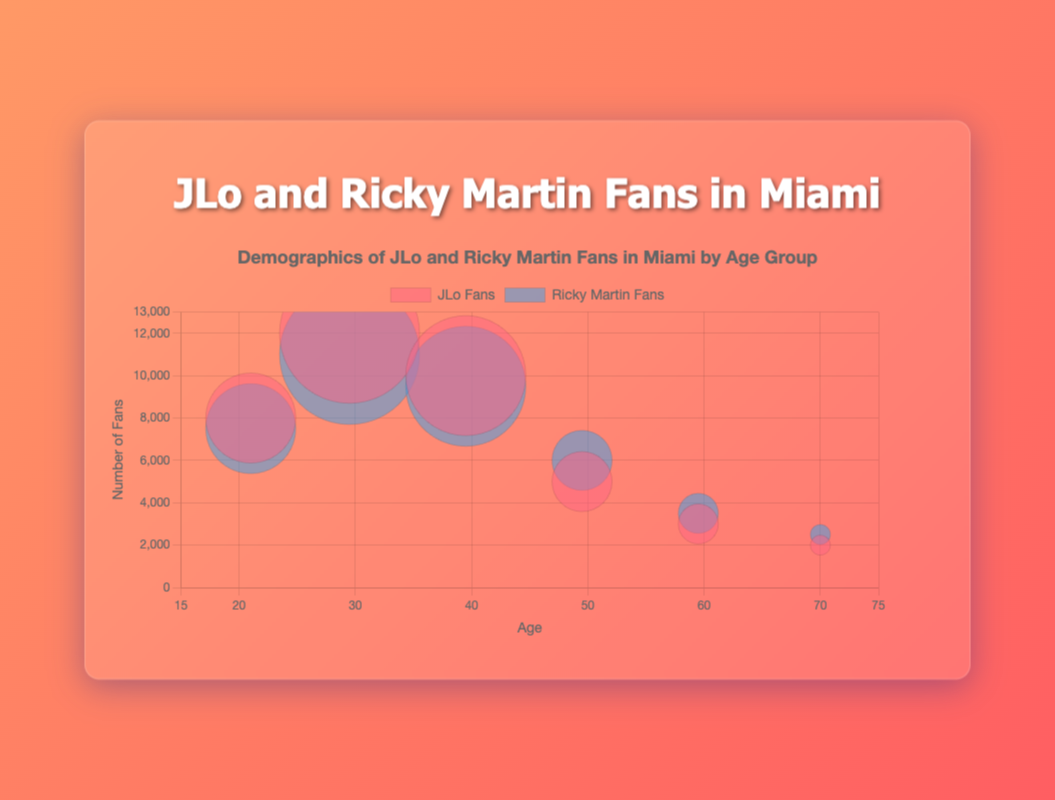What is the title of the chart? The title of the chart is located at the top and provides a summary of what the visual representation is about. The title reads "Demographics of JLo and Ricky Martin Fans in Miami by Age Group."
Answer: Demographics of JLo and Ricky Martin Fans in Miami by Age Group Which age group has the highest number of JLo fans? By looking at the y-axis values of the red bubbles (representing JLo fans), we can see which bubble goes the highest. The 25-34 age group has the highest y-coordinate at 12,000 fans.
Answer: 25-34 What is the average concert attendance for the 35-44 age group for both fans combined? To find the average concert attendance, we look at the data for both JLo and Ricky Martin fans in the 35-44 age group. The average concert attendance is directly provided, represented by the bubble size (radius). For this age group, it is 6,000.
Answer: 6,000 How many more JLo fans than Ricky Martin fans are there in the 18-24 age group? We compare the number of JLo and Ricky Martin fans in the 18-24 age group. JLo has 8,000 fans, while Ricky Martin has 7,500 fans. The difference is 8,000 - 7,500 = 500.
Answer: 500 Which fan group has larger bubbles overall, JLo or Ricky Martin? By comparing the transparency and size of the bubbles, the JLo fans (red bubbles) generally appear to have larger radii, indicating higher average concert attendance across most age groups.
Answer: JLo What is the y-axis range in the chart? The y-axis range can be determined by looking at the minimum and maximum values along the y-axis. It ranges from 0 to 13,000, as seen from the chart's axis labels.
Answer: 0 to 13,000 Which age group has the smallest difference in the number of fans between JLo and Ricky Martin fans? We need to look at each age group's fan numbers and compute the absolute difference. The smallest difference is in the 55-64 age group, where JLo has 3,000 fans and Ricky Martin has 3,500 fans, resulting in a difference of 500.
Answer: 55-64 By what percentage do Ricky Martin fans decrease from the 25-34 age group to the 65+ age group? We calculate the percentage decrease in Ricky Martin fans from 11,000 in the 25-34 age group to 2,500 in the 65+ age group. The decrease is 11,000 - 2,500 = 8,500. The percentage decrease is (8,500 / 11,000) * 100 = 77.27%.
Answer: 77.27% Which age group has a larger relative difference in fan numbers, the 35-44 or 45-54 age groups? For 35-44: JLo fans are 10,000, Ricky Martin fans are 9,500. Difference: 10,000 - 9,500 = 500. For 45-54: JLo fans are 5,000, Ricky Martin fans are 6,000. Difference: 6,000 - 5,000 = 1,000. Therefore, the 45-54 age group has a larger difference.
Answer: 45-54 What is the average number of fans for Ricky Martin in all age groups? To calculate the average number of fans for Ricky Martin across all age groups, we add up the number of fans and divide by the total number of age groups. (7,500 + 11,000 + 9,500 + 6,000 + 3,500 + 2,500) / 6 = 40,000 / 6 ≈ 6,667 fans per age group.
Answer: 6,667 